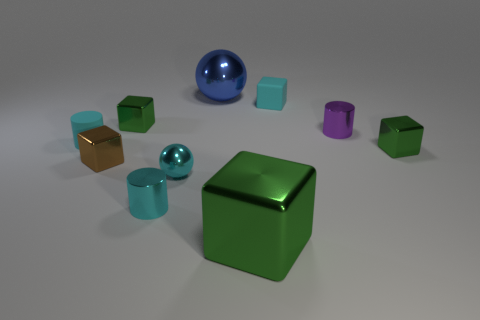The large shiny thing that is behind the cylinder in front of the small green shiny object that is to the right of the purple metal cylinder is what color? blue 